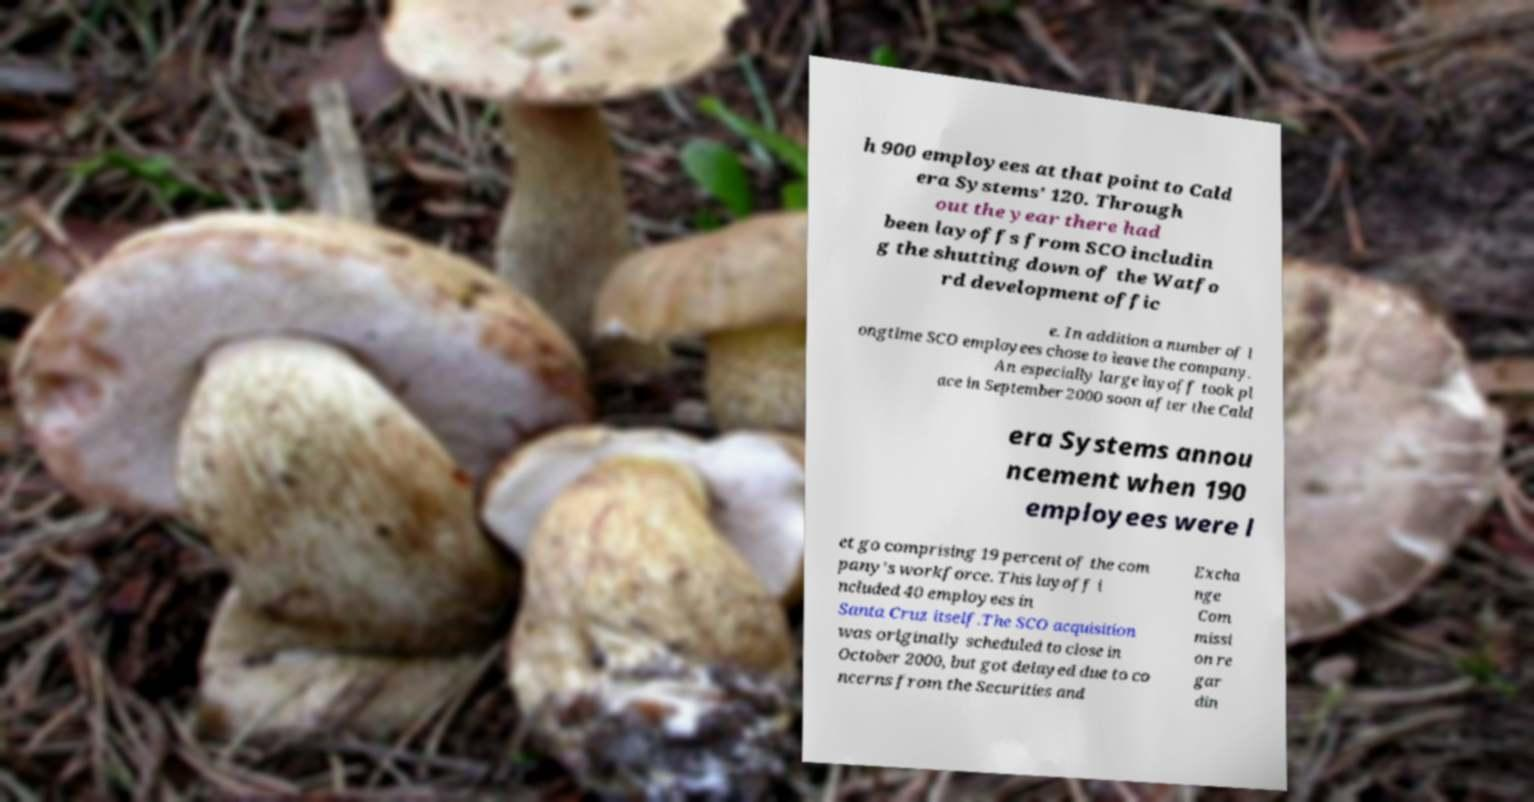I need the written content from this picture converted into text. Can you do that? h 900 employees at that point to Cald era Systems' 120. Through out the year there had been layoffs from SCO includin g the shutting down of the Watfo rd development offic e. In addition a number of l ongtime SCO employees chose to leave the company. An especially large layoff took pl ace in September 2000 soon after the Cald era Systems annou ncement when 190 employees were l et go comprising 19 percent of the com pany's workforce. This layoff i ncluded 40 employees in Santa Cruz itself.The SCO acquisition was originally scheduled to close in October 2000, but got delayed due to co ncerns from the Securities and Excha nge Com missi on re gar din 